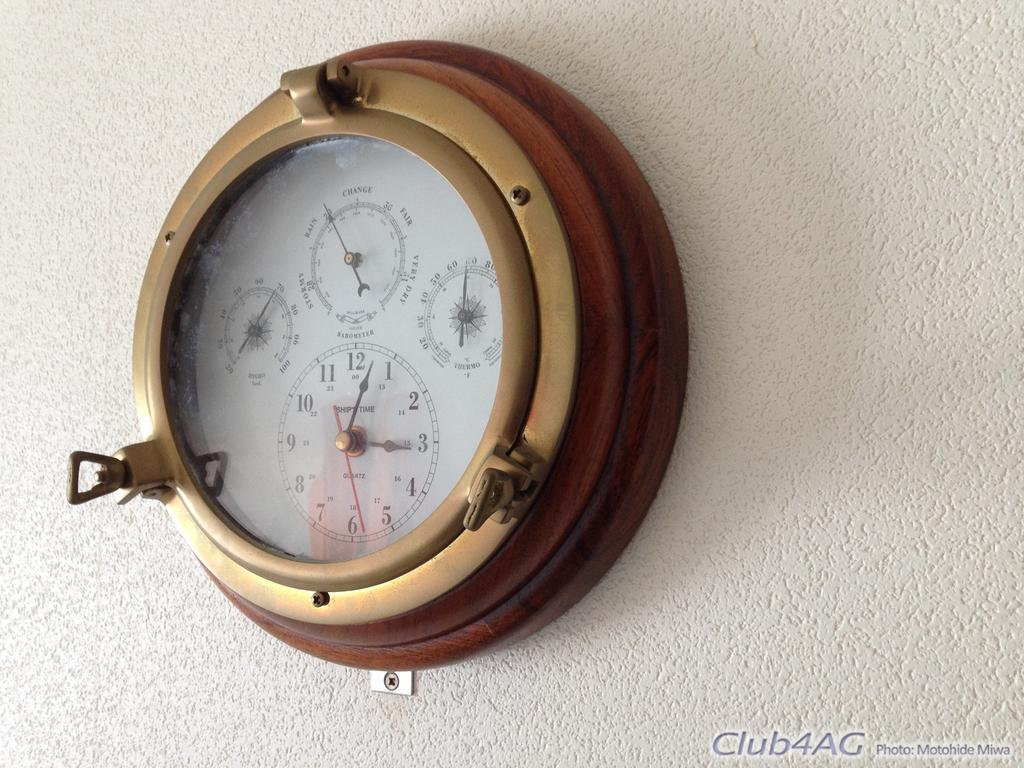<image>
Present a compact description of the photo's key features. A clock with additional gauges including the "thermo" is shown hanging on the wall. 